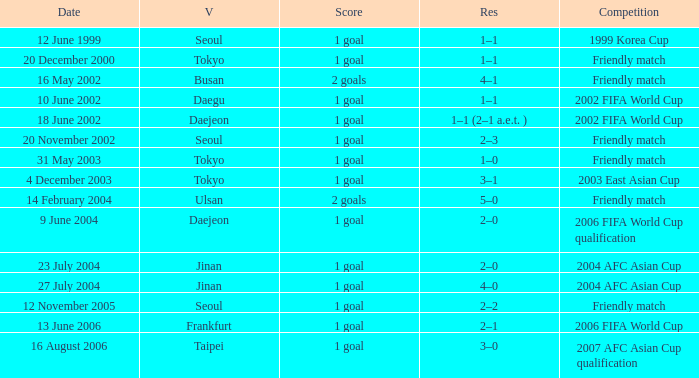What is the competition that occured on 27 July 2004? 2004 AFC Asian Cup. 